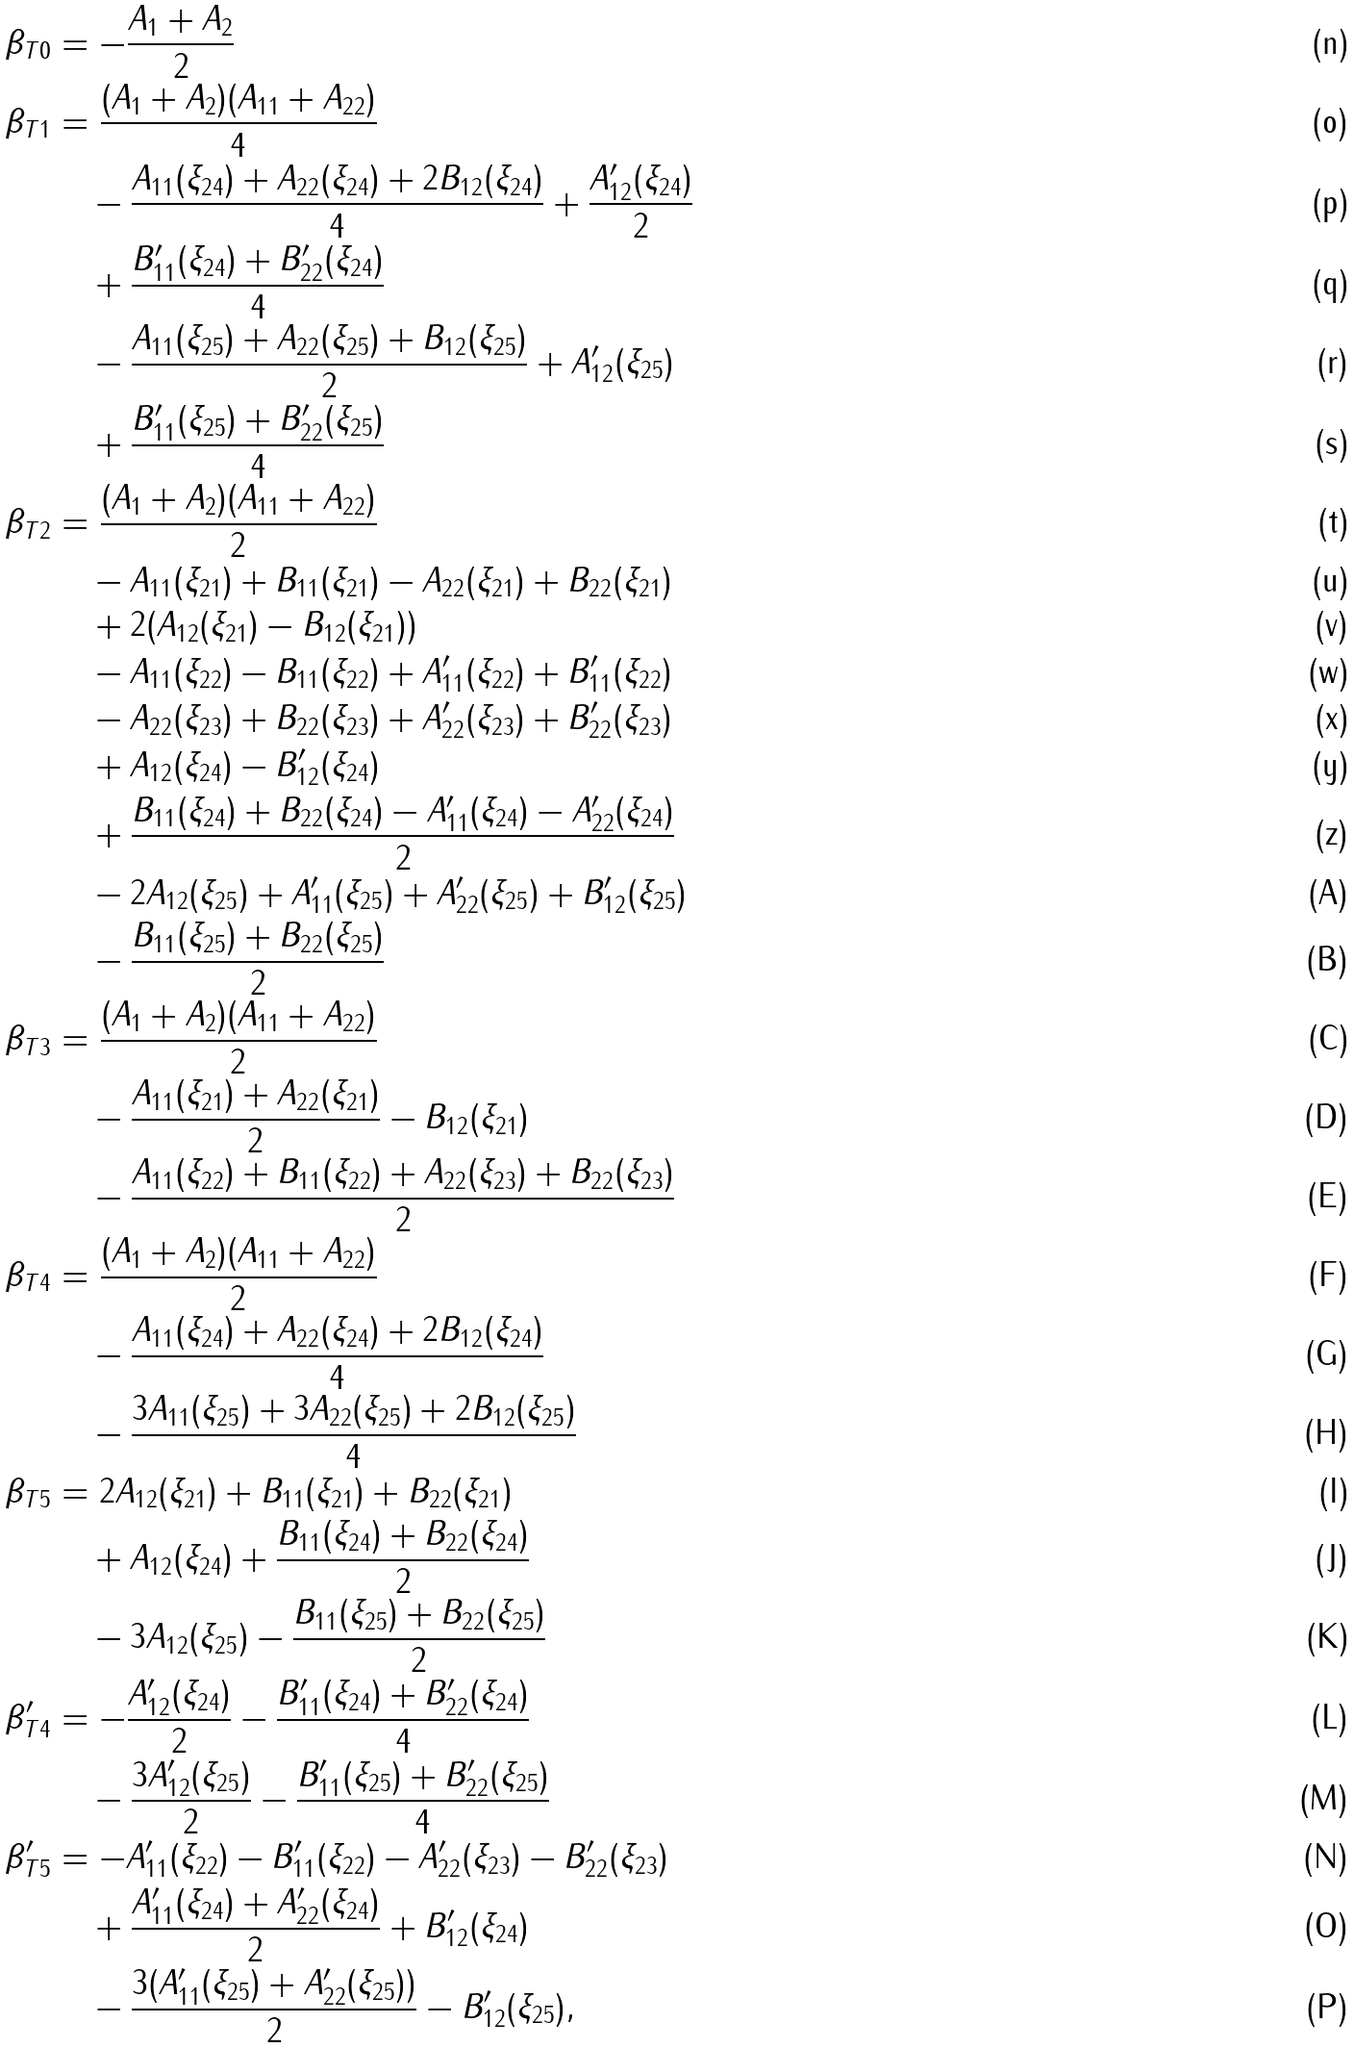Convert formula to latex. <formula><loc_0><loc_0><loc_500><loc_500>\beta _ { T 0 } & = - \frac { A _ { 1 } + A _ { 2 } } { 2 } \\ \beta _ { T 1 } & = \frac { ( A _ { 1 } + A _ { 2 } ) ( A _ { 1 1 } + A _ { 2 2 } ) } { 4 } \\ & \quad - \frac { A _ { 1 1 } ( \xi _ { 2 4 } ) + A _ { 2 2 } ( \xi _ { 2 4 } ) + 2 B _ { 1 2 } ( \xi _ { 2 4 } ) } { 4 } + \frac { A ^ { \prime } _ { 1 2 } ( \xi _ { 2 4 } ) } { 2 } \\ & \quad + \frac { B ^ { \prime } _ { 1 1 } ( \xi _ { 2 4 } ) + B ^ { \prime } _ { 2 2 } ( \xi _ { 2 4 } ) } { 4 } \\ & \quad - \frac { A _ { 1 1 } ( \xi _ { 2 5 } ) + A _ { 2 2 } ( \xi _ { 2 5 } ) + B _ { 1 2 } ( \xi _ { 2 5 } ) } { 2 } + A ^ { \prime } _ { 1 2 } ( \xi _ { 2 5 } ) \\ & \quad + \frac { B ^ { \prime } _ { 1 1 } ( \xi _ { 2 5 } ) + B ^ { \prime } _ { 2 2 } ( \xi _ { 2 5 } ) } { 4 } \\ \beta _ { T 2 } & = \frac { ( A _ { 1 } + A _ { 2 } ) ( A _ { 1 1 } + A _ { 2 2 } ) } { 2 } \\ & \quad - A _ { 1 1 } ( \xi _ { 2 1 } ) + B _ { 1 1 } ( \xi _ { 2 1 } ) - A _ { 2 2 } ( \xi _ { 2 1 } ) + B _ { 2 2 } ( \xi _ { 2 1 } ) \\ & \quad + 2 ( A _ { 1 2 } ( \xi _ { 2 1 } ) - B _ { 1 2 } ( \xi _ { 2 1 } ) ) \\ & \quad - A _ { 1 1 } ( \xi _ { 2 2 } ) - B _ { 1 1 } ( \xi _ { 2 2 } ) + A ^ { \prime } _ { 1 1 } ( \xi _ { 2 2 } ) + B ^ { \prime } _ { 1 1 } ( \xi _ { 2 2 } ) \\ & \quad - A _ { 2 2 } ( \xi _ { 2 3 } ) + B _ { 2 2 } ( \xi _ { 2 3 } ) + A ^ { \prime } _ { 2 2 } ( \xi _ { 2 3 } ) + B ^ { \prime } _ { 2 2 } ( \xi _ { 2 3 } ) \\ & \quad + A _ { 1 2 } ( \xi _ { 2 4 } ) - B ^ { \prime } _ { 1 2 } ( \xi _ { 2 4 } ) \\ & \quad + \frac { B _ { 1 1 } ( \xi _ { 2 4 } ) + B _ { 2 2 } ( \xi _ { 2 4 } ) - A ^ { \prime } _ { 1 1 } ( \xi _ { 2 4 } ) - A ^ { \prime } _ { 2 2 } ( \xi _ { 2 4 } ) } { 2 } \\ & \quad - 2 A _ { 1 2 } ( \xi _ { 2 5 } ) + A ^ { \prime } _ { 1 1 } ( \xi _ { 2 5 } ) + A ^ { \prime } _ { 2 2 } ( \xi _ { 2 5 } ) + B ^ { \prime } _ { 1 2 } ( \xi _ { 2 5 } ) \\ & \quad - \frac { B _ { 1 1 } ( \xi _ { 2 5 } ) + B _ { 2 2 } ( \xi _ { 2 5 } ) } { 2 } \\ \beta _ { T 3 } & = \frac { ( A _ { 1 } + A _ { 2 } ) ( A _ { 1 1 } + A _ { 2 2 } ) } { 2 } \\ & \quad - \frac { A _ { 1 1 } ( \xi _ { 2 1 } ) + A _ { 2 2 } ( \xi _ { 2 1 } ) } { 2 } - B _ { 1 2 } ( \xi _ { 2 1 } ) \\ & \quad - \frac { A _ { 1 1 } ( \xi _ { 2 2 } ) + B _ { 1 1 } ( \xi _ { 2 2 } ) + A _ { 2 2 } ( \xi _ { 2 3 } ) + B _ { 2 2 } ( \xi _ { 2 3 } ) } { 2 } \\ \beta _ { T 4 } & = \frac { ( A _ { 1 } + A _ { 2 } ) ( A _ { 1 1 } + A _ { 2 2 } ) } { 2 } \\ & \quad - \frac { A _ { 1 1 } ( \xi _ { 2 4 } ) + A _ { 2 2 } ( \xi _ { 2 4 } ) + 2 B _ { 1 2 } ( \xi _ { 2 4 } ) } { 4 } \\ & \quad - \frac { 3 A _ { 1 1 } ( \xi _ { 2 5 } ) + 3 A _ { 2 2 } ( \xi _ { 2 5 } ) + 2 B _ { 1 2 } ( \xi _ { 2 5 } ) } { 4 } \\ \beta _ { T 5 } & = 2 A _ { 1 2 } ( \xi _ { 2 1 } ) + B _ { 1 1 } ( \xi _ { 2 1 } ) + B _ { 2 2 } ( \xi _ { 2 1 } ) \\ & \quad + A _ { 1 2 } ( \xi _ { 2 4 } ) + \frac { B _ { 1 1 } ( \xi _ { 2 4 } ) + B _ { 2 2 } ( \xi _ { 2 4 } ) } { 2 } \\ & \quad - 3 A _ { 1 2 } ( \xi _ { 2 5 } ) - \frac { B _ { 1 1 } ( \xi _ { 2 5 } ) + B _ { 2 2 } ( \xi _ { 2 5 } ) } { 2 } \\ \beta ^ { \prime } _ { T 4 } & = - \frac { A ^ { \prime } _ { 1 2 } ( \xi _ { 2 4 } ) } { 2 } - \frac { B ^ { \prime } _ { 1 1 } ( \xi _ { 2 4 } ) + B ^ { \prime } _ { 2 2 } ( \xi _ { 2 4 } ) } { 4 } \\ & \quad - \frac { 3 A ^ { \prime } _ { 1 2 } ( \xi _ { 2 5 } ) } { 2 } - \frac { B ^ { \prime } _ { 1 1 } ( \xi _ { 2 5 } ) + B ^ { \prime } _ { 2 2 } ( \xi _ { 2 5 } ) } { 4 } \\ \beta ^ { \prime } _ { T 5 } & = - A ^ { \prime } _ { 1 1 } ( \xi _ { 2 2 } ) - B ^ { \prime } _ { 1 1 } ( \xi _ { 2 2 } ) - A ^ { \prime } _ { 2 2 } ( \xi _ { 2 3 } ) - B ^ { \prime } _ { 2 2 } ( \xi _ { 2 3 } ) \\ & \quad + \frac { A ^ { \prime } _ { 1 1 } ( \xi _ { 2 4 } ) + A ^ { \prime } _ { 2 2 } ( \xi _ { 2 4 } ) } { 2 } + B ^ { \prime } _ { 1 2 } ( \xi _ { 2 4 } ) \\ & \quad - \frac { 3 ( A ^ { \prime } _ { 1 1 } ( \xi _ { 2 5 } ) + A ^ { \prime } _ { 2 2 } ( \xi _ { 2 5 } ) ) } { 2 } - B ^ { \prime } _ { 1 2 } ( \xi _ { 2 5 } ) ,</formula> 